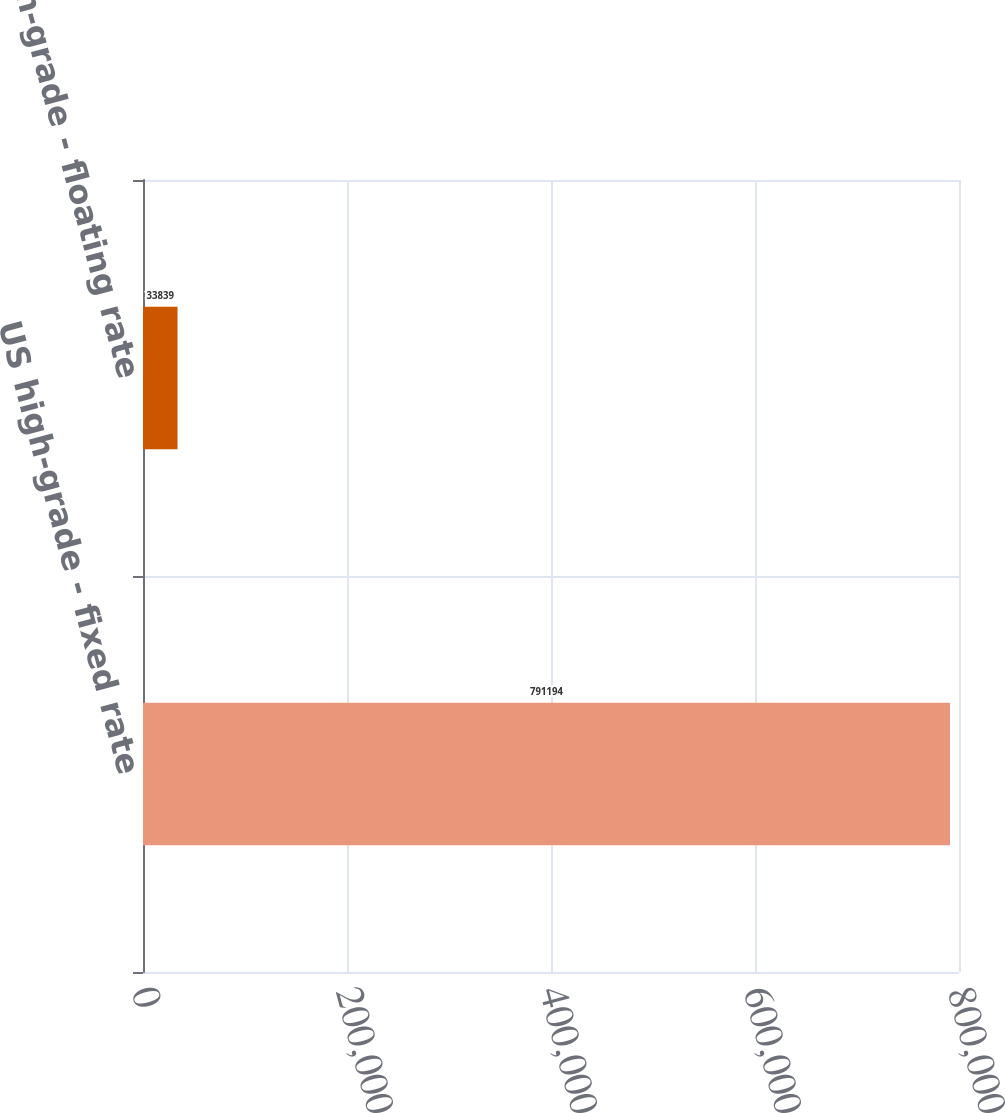Convert chart to OTSL. <chart><loc_0><loc_0><loc_500><loc_500><bar_chart><fcel>US high-grade - fixed rate<fcel>US high-grade - floating rate<nl><fcel>791194<fcel>33839<nl></chart> 